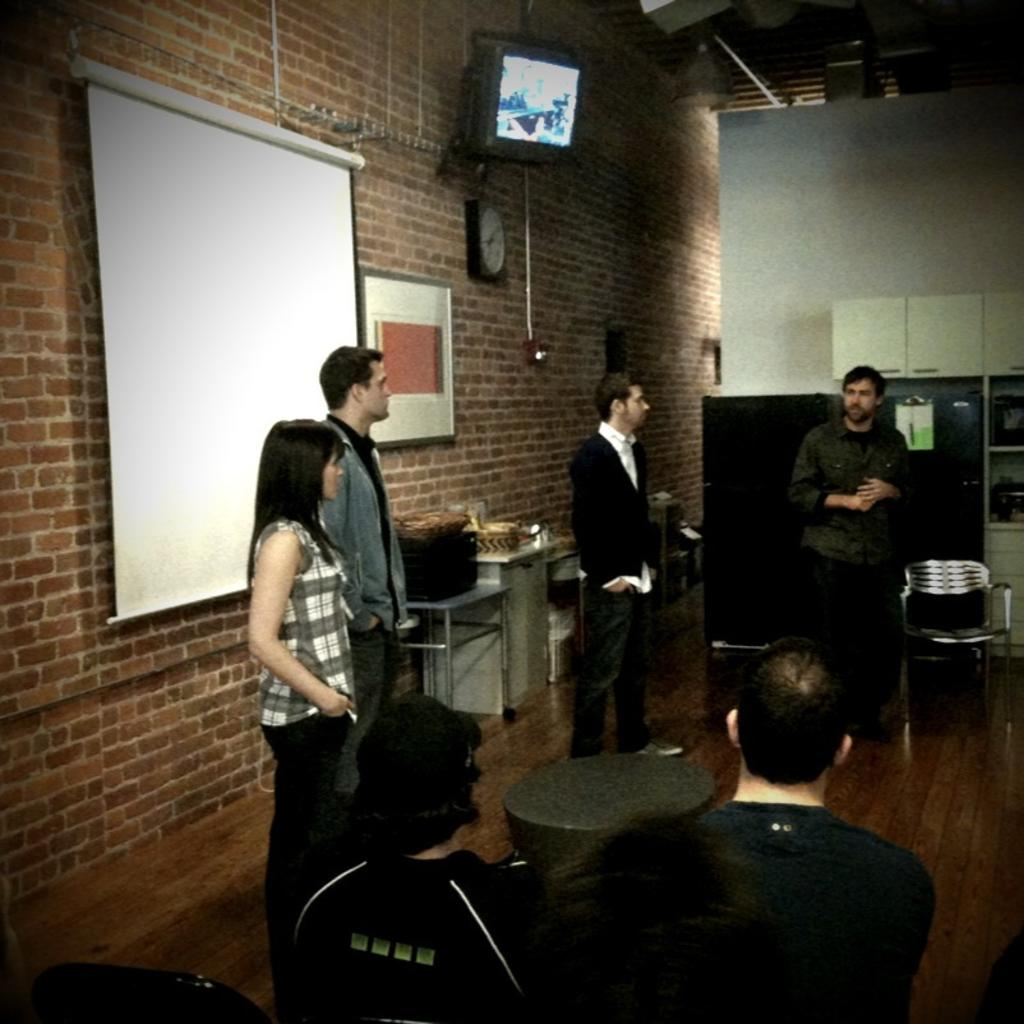What are the people in the image doing? There are persons sitting and standing in the image. What is present in the image that might be used for holding or displaying items? There is a table in the image. What can be seen in the background of the image? There is a wall, a television, and a projector in the background of the image. What is on the projector in the image? There are many objects on the projector. What type of plant is growing on the news in the image? There is no plant or news present in the image. What type of sail can be seen on the projector in the image? There is no sail present in the image; the objects on the projector are not specified. 